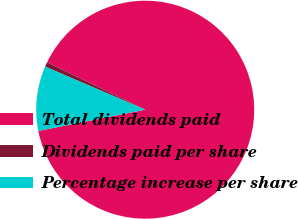Convert chart to OTSL. <chart><loc_0><loc_0><loc_500><loc_500><pie_chart><fcel>Total dividends paid<fcel>Dividends paid per share<fcel>Percentage increase per share<nl><fcel>89.72%<fcel>0.69%<fcel>9.59%<nl></chart> 